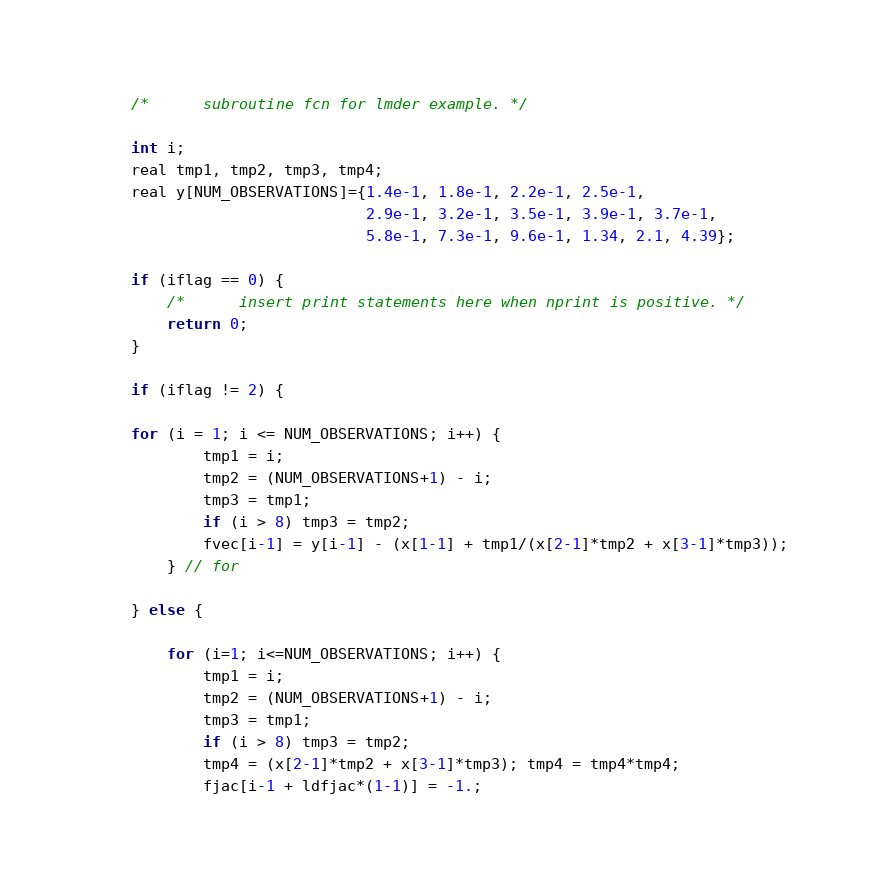Convert code to text. <code><loc_0><loc_0><loc_500><loc_500><_Cuda_>    /*      subroutine fcn for lmder example. */

    int i;
    real tmp1, tmp2, tmp3, tmp4;
    real y[NUM_OBSERVATIONS]={1.4e-1, 1.8e-1, 2.2e-1, 2.5e-1, 
                              2.9e-1, 3.2e-1, 3.5e-1, 3.9e-1, 3.7e-1, 
                              5.8e-1, 7.3e-1, 9.6e-1, 1.34, 2.1, 4.39};

    if (iflag == 0) {
        /*      insert print statements here when nprint is positive. */
        return 0;
    }

    if (iflag != 2) {

	for (i = 1; i <= NUM_OBSERVATIONS; i++) {
            tmp1 = i;
            tmp2 = (NUM_OBSERVATIONS+1) - i;
            tmp3 = tmp1;
            if (i > 8) tmp3 = tmp2;
            fvec[i-1] = y[i-1] - (x[1-1] + tmp1/(x[2-1]*tmp2 + x[3-1]*tmp3));
        } // for

    } else { 

        for (i=1; i<=NUM_OBSERVATIONS; i++) {
            tmp1 = i;
            tmp2 = (NUM_OBSERVATIONS+1) - i;
            tmp3 = tmp1;
            if (i > 8) tmp3 = tmp2;
            tmp4 = (x[2-1]*tmp2 + x[3-1]*tmp3); tmp4 = tmp4*tmp4;
            fjac[i-1 + ldfjac*(1-1)] = -1.;</code> 